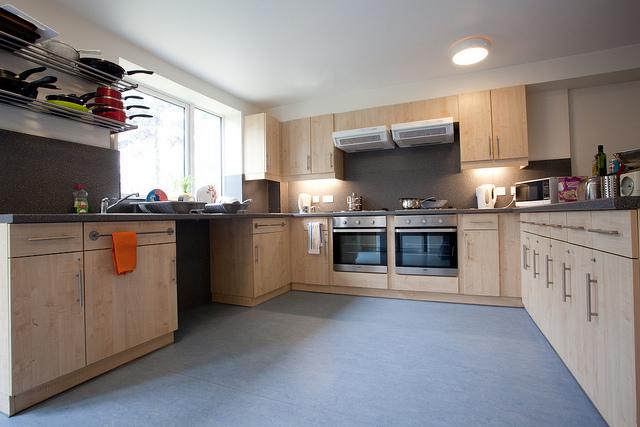How many ovens are in this kitchen?
Write a very short answer. 2. Where are the 3 red pans located?
Short answer required. Above sink. How many dish towels are hanging on towel bars in this kitchen?
Give a very brief answer. 2. 